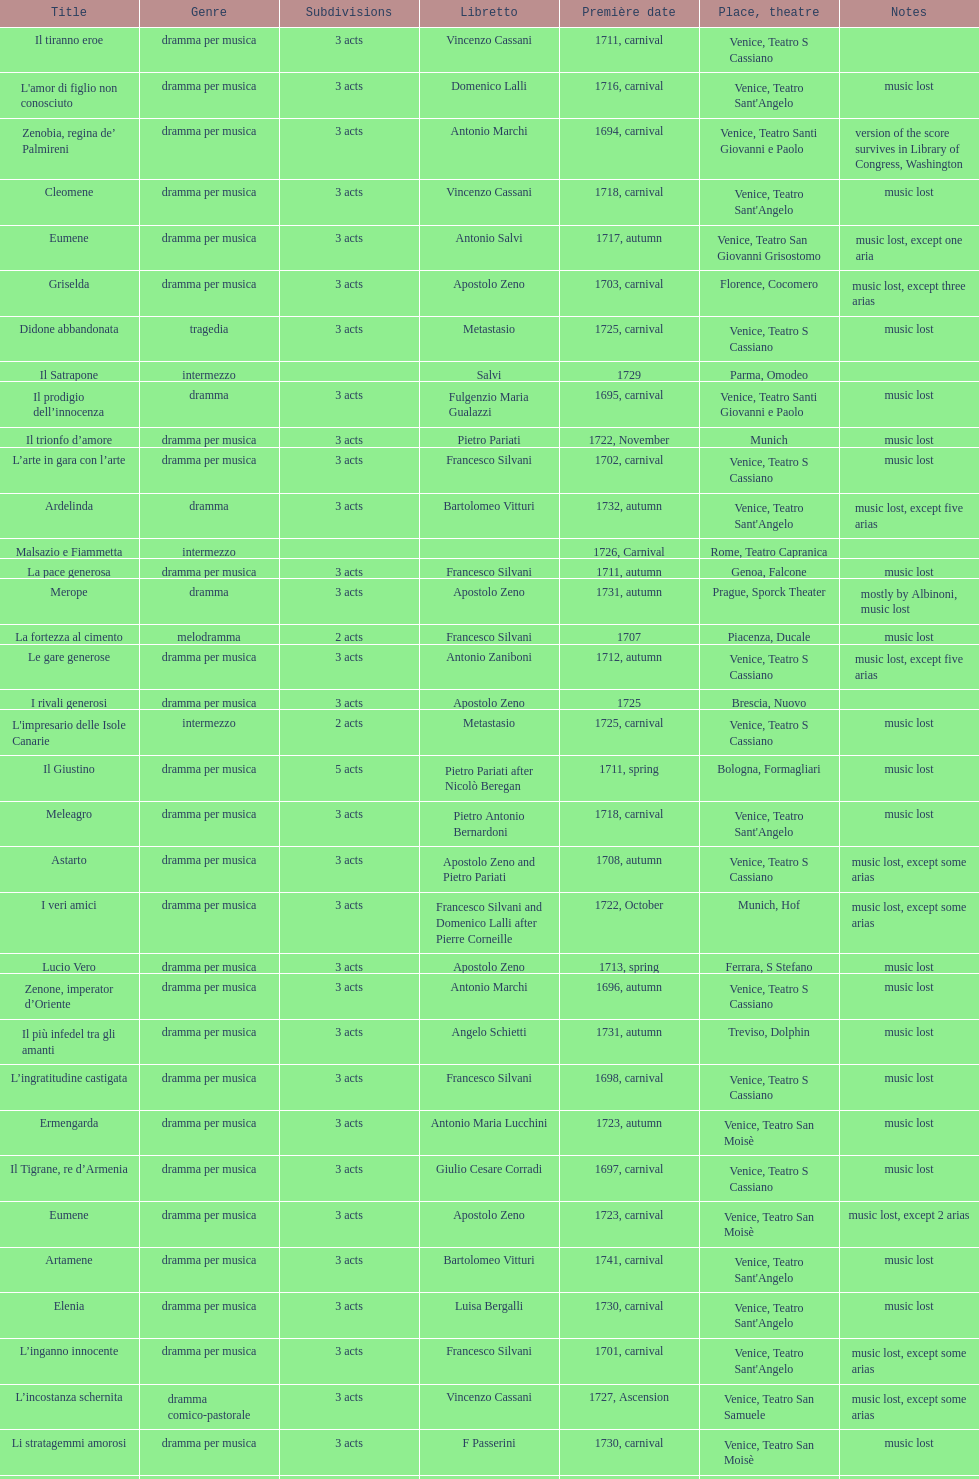How many operas on this list has at least 3 acts? 51. 